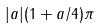<formula> <loc_0><loc_0><loc_500><loc_500>| a | ( 1 + a / 4 ) \pi</formula> 